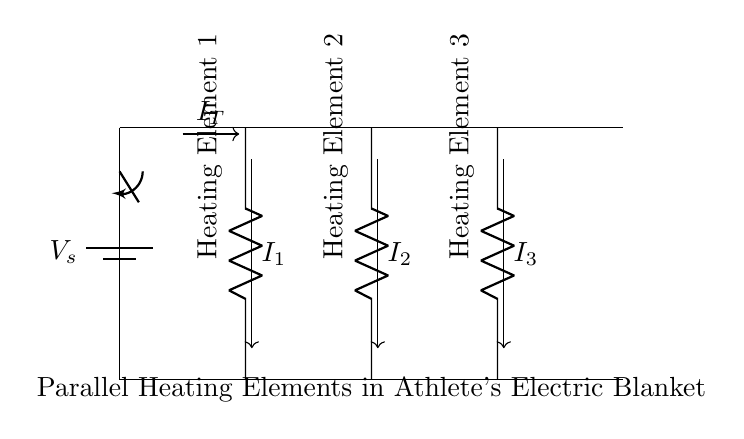What is the total voltage supplied to the heating elements? The total voltage is determined by the battery, indicated as **Vs** in the diagram. Since the battery is the only voltage source, the voltage across each heating element is equal to this supply voltage.
Answer: Vs How many heating elements are connected in parallel? The diagram clearly depicts three heating elements, each connected between the same voltage source and therefore able to operate independently.
Answer: Three What is the current direction in the circuit? The arrows in the diagram show the direction of current flow, labelled as **It** for total current and **I1**, **I2**, and **I3** for the currents through each heating element.
Answer: From top to bottom If one heating element fails, what happens to the others? In a parallel circuit, if one heating element fails (i.e., open circuit), the remaining ones will continue to operate because they maintain independent paths for current.
Answer: They continue working What indicates that this circuit is a parallel arrangement? The components are arranged so that they share the same two nodes (voltage source), allowing multiple paths for current; this is characteristic of parallel connections.
Answer: Shared nodes What is the significance of the switch in this circuit? The switch controls the total circuit flow; when closed, it allows current to flow through the heating elements, whereas when opened, it disconnects the circuit entirely.
Answer: It controls power 